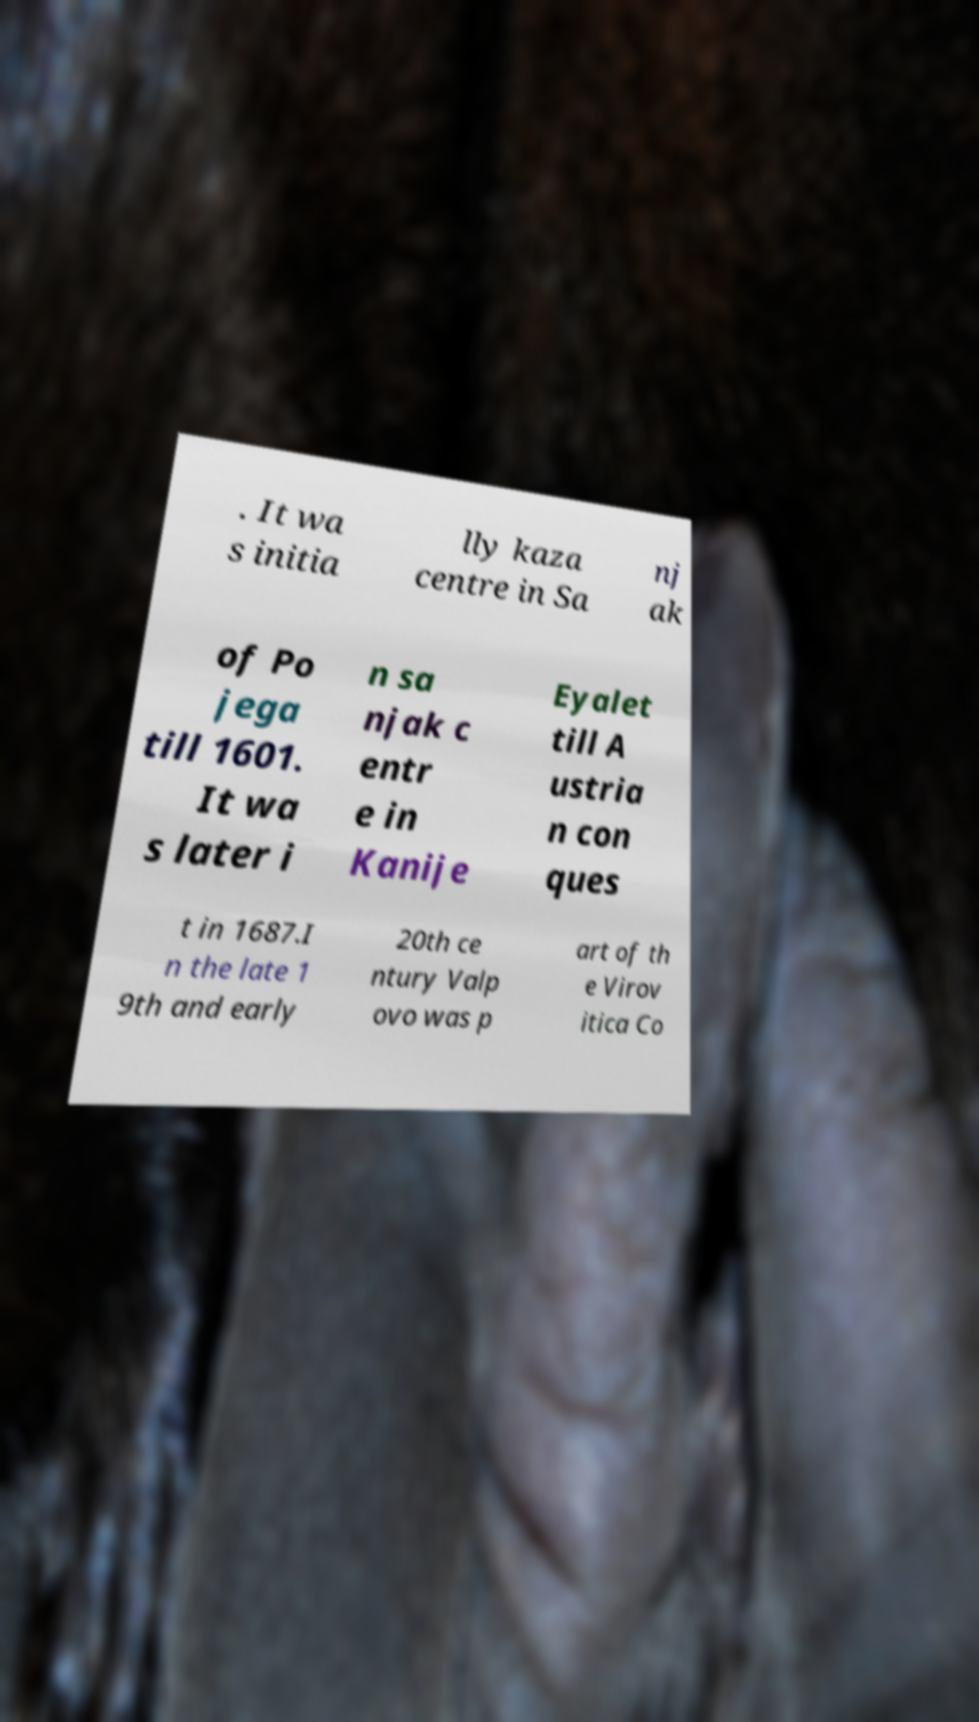Could you assist in decoding the text presented in this image and type it out clearly? . It wa s initia lly kaza centre in Sa nj ak of Po jega till 1601. It wa s later i n sa njak c entr e in Kanije Eyalet till A ustria n con ques t in 1687.I n the late 1 9th and early 20th ce ntury Valp ovo was p art of th e Virov itica Co 